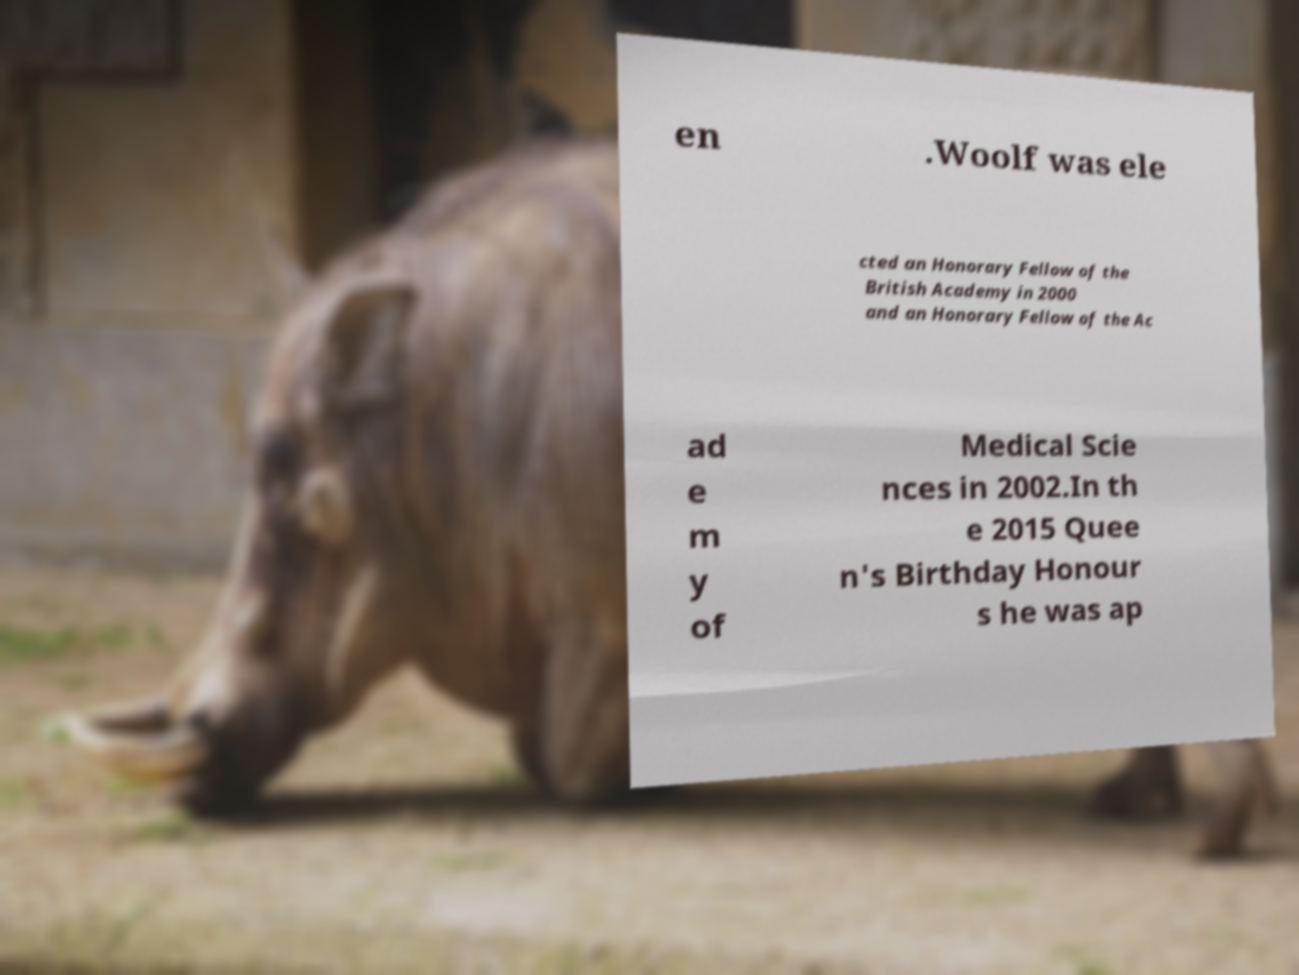Could you extract and type out the text from this image? en .Woolf was ele cted an Honorary Fellow of the British Academy in 2000 and an Honorary Fellow of the Ac ad e m y of Medical Scie nces in 2002.In th e 2015 Quee n's Birthday Honour s he was ap 